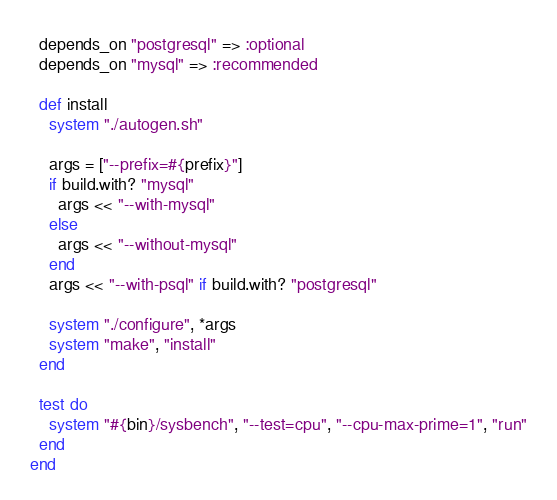Convert code to text. <code><loc_0><loc_0><loc_500><loc_500><_Ruby_>  depends_on "postgresql" => :optional
  depends_on "mysql" => :recommended

  def install
    system "./autogen.sh"

    args = ["--prefix=#{prefix}"]
    if build.with? "mysql"
      args << "--with-mysql"
    else
      args << "--without-mysql"
    end
    args << "--with-psql" if build.with? "postgresql"

    system "./configure", *args
    system "make", "install"
  end

  test do
    system "#{bin}/sysbench", "--test=cpu", "--cpu-max-prime=1", "run"
  end
end
</code> 